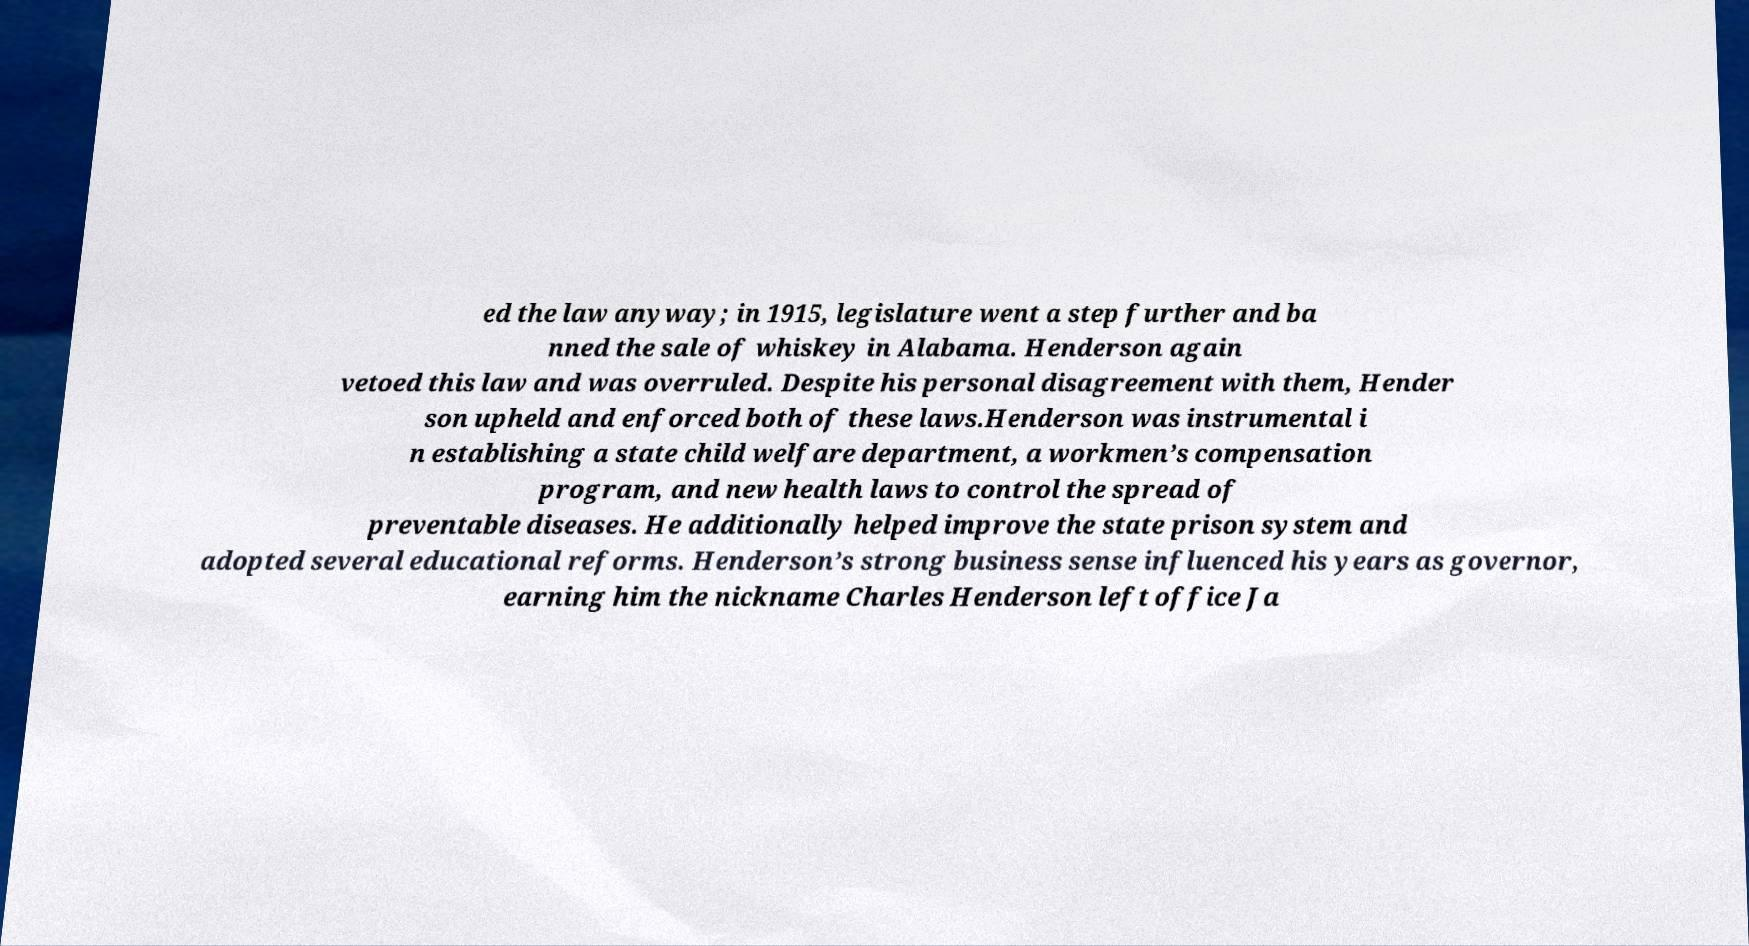I need the written content from this picture converted into text. Can you do that? ed the law anyway; in 1915, legislature went a step further and ba nned the sale of whiskey in Alabama. Henderson again vetoed this law and was overruled. Despite his personal disagreement with them, Hender son upheld and enforced both of these laws.Henderson was instrumental i n establishing a state child welfare department, a workmen’s compensation program, and new health laws to control the spread of preventable diseases. He additionally helped improve the state prison system and adopted several educational reforms. Henderson’s strong business sense influenced his years as governor, earning him the nickname Charles Henderson left office Ja 